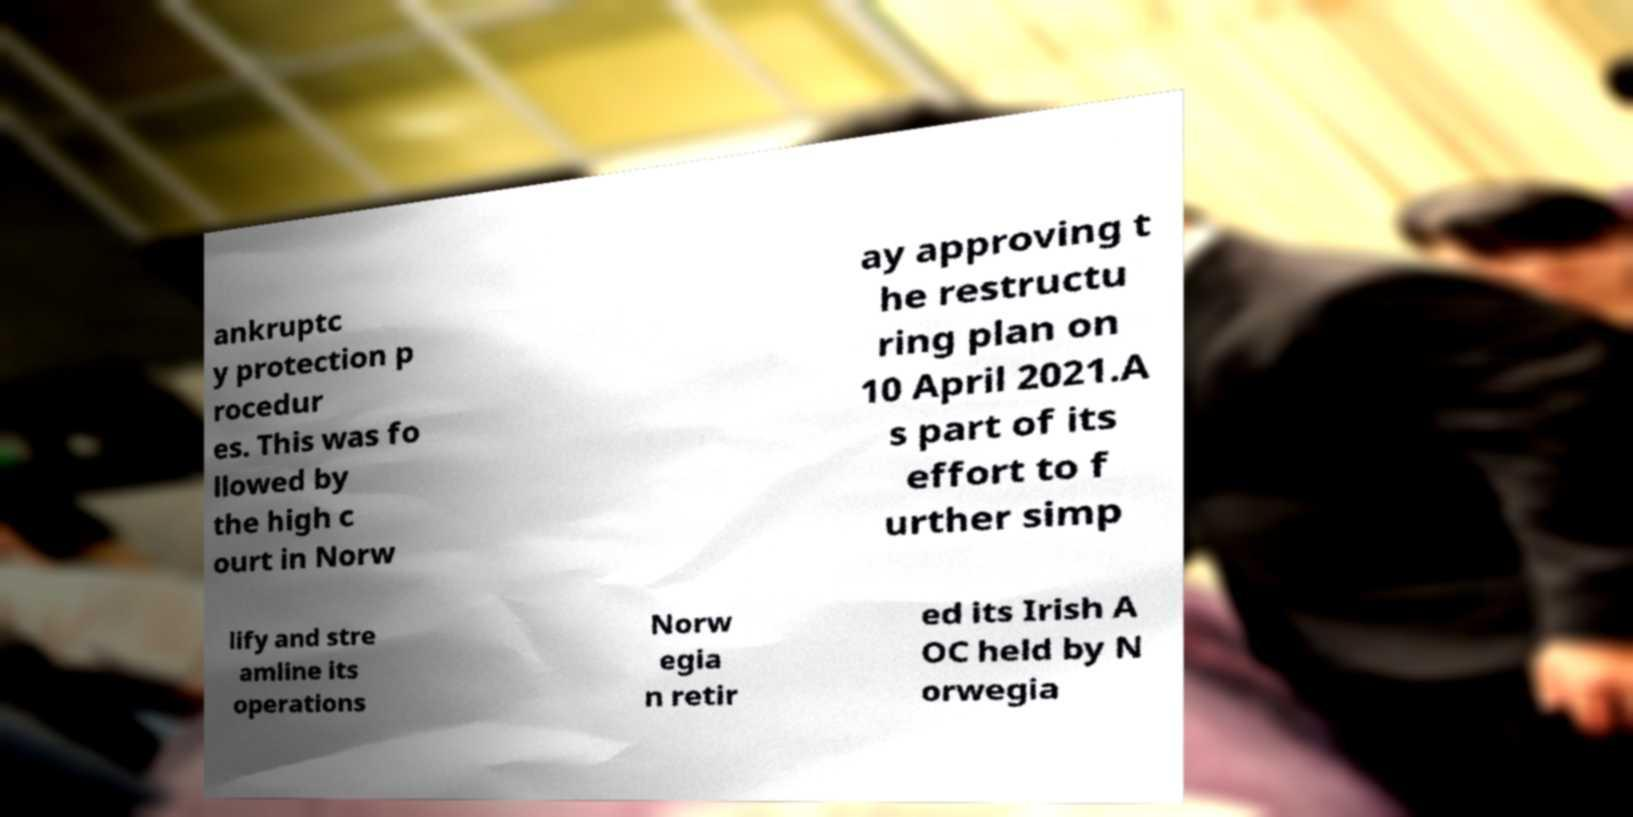What messages or text are displayed in this image? I need them in a readable, typed format. ankruptc y protection p rocedur es. This was fo llowed by the high c ourt in Norw ay approving t he restructu ring plan on 10 April 2021.A s part of its effort to f urther simp lify and stre amline its operations Norw egia n retir ed its Irish A OC held by N orwegia 